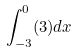Convert formula to latex. <formula><loc_0><loc_0><loc_500><loc_500>\int _ { - 3 } ^ { 0 } ( 3 ) d x</formula> 